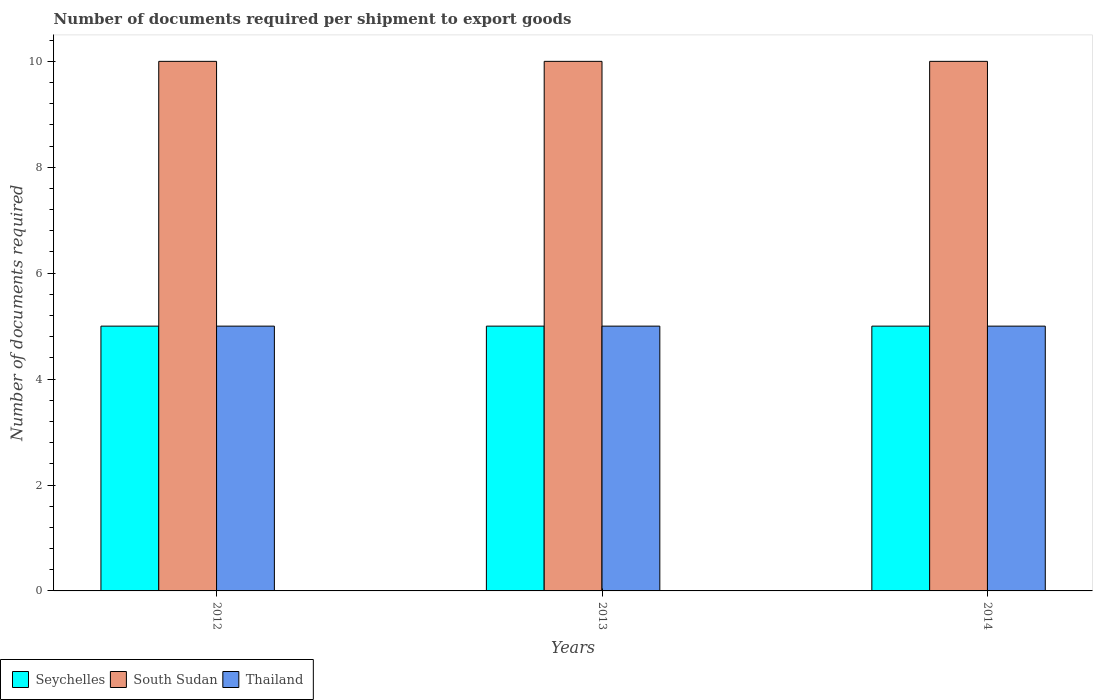Are the number of bars per tick equal to the number of legend labels?
Provide a short and direct response. Yes. How many bars are there on the 2nd tick from the left?
Provide a short and direct response. 3. How many bars are there on the 1st tick from the right?
Your answer should be very brief. 3. What is the label of the 3rd group of bars from the left?
Make the answer very short. 2014. In how many cases, is the number of bars for a given year not equal to the number of legend labels?
Offer a terse response. 0. What is the number of documents required per shipment to export goods in Thailand in 2014?
Give a very brief answer. 5. Across all years, what is the maximum number of documents required per shipment to export goods in Thailand?
Your response must be concise. 5. Across all years, what is the minimum number of documents required per shipment to export goods in Thailand?
Your response must be concise. 5. In which year was the number of documents required per shipment to export goods in Seychelles minimum?
Provide a short and direct response. 2012. What is the total number of documents required per shipment to export goods in Seychelles in the graph?
Make the answer very short. 15. What is the difference between the number of documents required per shipment to export goods in Seychelles in 2012 and the number of documents required per shipment to export goods in South Sudan in 2013?
Your response must be concise. -5. What is the difference between the highest and the second highest number of documents required per shipment to export goods in Thailand?
Provide a succinct answer. 0. What does the 2nd bar from the left in 2012 represents?
Give a very brief answer. South Sudan. What does the 2nd bar from the right in 2012 represents?
Make the answer very short. South Sudan. Are all the bars in the graph horizontal?
Offer a very short reply. No. How many years are there in the graph?
Provide a short and direct response. 3. What is the difference between two consecutive major ticks on the Y-axis?
Give a very brief answer. 2. Are the values on the major ticks of Y-axis written in scientific E-notation?
Your answer should be compact. No. Does the graph contain any zero values?
Provide a short and direct response. No. Does the graph contain grids?
Make the answer very short. No. Where does the legend appear in the graph?
Offer a very short reply. Bottom left. How many legend labels are there?
Your answer should be compact. 3. What is the title of the graph?
Make the answer very short. Number of documents required per shipment to export goods. Does "Dominica" appear as one of the legend labels in the graph?
Ensure brevity in your answer.  No. What is the label or title of the Y-axis?
Make the answer very short. Number of documents required. What is the Number of documents required of Seychelles in 2012?
Provide a succinct answer. 5. What is the Number of documents required of South Sudan in 2012?
Make the answer very short. 10. What is the Number of documents required in Thailand in 2014?
Provide a short and direct response. 5. Across all years, what is the maximum Number of documents required of Seychelles?
Your response must be concise. 5. Across all years, what is the minimum Number of documents required in Seychelles?
Make the answer very short. 5. Across all years, what is the minimum Number of documents required in Thailand?
Provide a short and direct response. 5. What is the total Number of documents required of Seychelles in the graph?
Your answer should be compact. 15. What is the total Number of documents required in South Sudan in the graph?
Provide a short and direct response. 30. What is the total Number of documents required of Thailand in the graph?
Your answer should be very brief. 15. What is the difference between the Number of documents required of South Sudan in 2012 and that in 2014?
Offer a terse response. 0. What is the difference between the Number of documents required of Thailand in 2012 and that in 2014?
Ensure brevity in your answer.  0. What is the difference between the Number of documents required of Seychelles in 2013 and that in 2014?
Your response must be concise. 0. What is the difference between the Number of documents required of Thailand in 2013 and that in 2014?
Give a very brief answer. 0. What is the difference between the Number of documents required in Seychelles in 2012 and the Number of documents required in South Sudan in 2013?
Make the answer very short. -5. What is the average Number of documents required of Seychelles per year?
Your answer should be compact. 5. What is the average Number of documents required in South Sudan per year?
Ensure brevity in your answer.  10. What is the average Number of documents required of Thailand per year?
Offer a very short reply. 5. In the year 2012, what is the difference between the Number of documents required of Seychelles and Number of documents required of Thailand?
Offer a terse response. 0. In the year 2013, what is the difference between the Number of documents required in Seychelles and Number of documents required in Thailand?
Give a very brief answer. 0. In the year 2014, what is the difference between the Number of documents required in Seychelles and Number of documents required in South Sudan?
Make the answer very short. -5. In the year 2014, what is the difference between the Number of documents required of South Sudan and Number of documents required of Thailand?
Your answer should be compact. 5. What is the ratio of the Number of documents required in Seychelles in 2012 to that in 2013?
Provide a succinct answer. 1. What is the ratio of the Number of documents required of South Sudan in 2012 to that in 2013?
Offer a terse response. 1. What is the ratio of the Number of documents required of Seychelles in 2012 to that in 2014?
Provide a succinct answer. 1. What is the ratio of the Number of documents required in Thailand in 2012 to that in 2014?
Offer a terse response. 1. What is the ratio of the Number of documents required of Seychelles in 2013 to that in 2014?
Provide a succinct answer. 1. What is the difference between the highest and the lowest Number of documents required in Seychelles?
Your response must be concise. 0. 